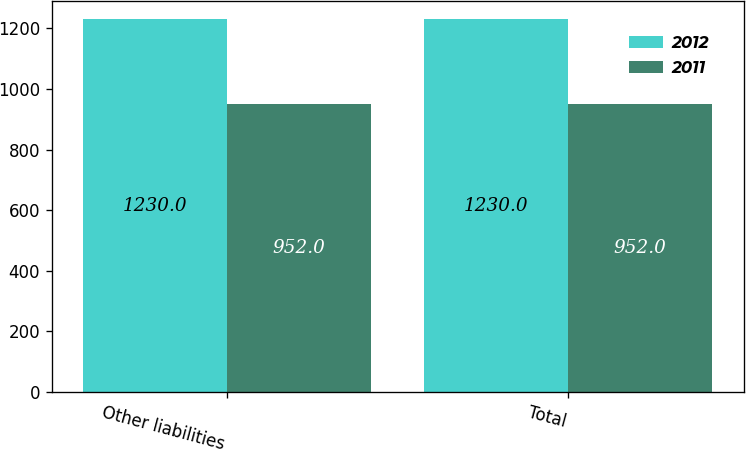Convert chart to OTSL. <chart><loc_0><loc_0><loc_500><loc_500><stacked_bar_chart><ecel><fcel>Other liabilities<fcel>Total<nl><fcel>2012<fcel>1230<fcel>1230<nl><fcel>2011<fcel>952<fcel>952<nl></chart> 